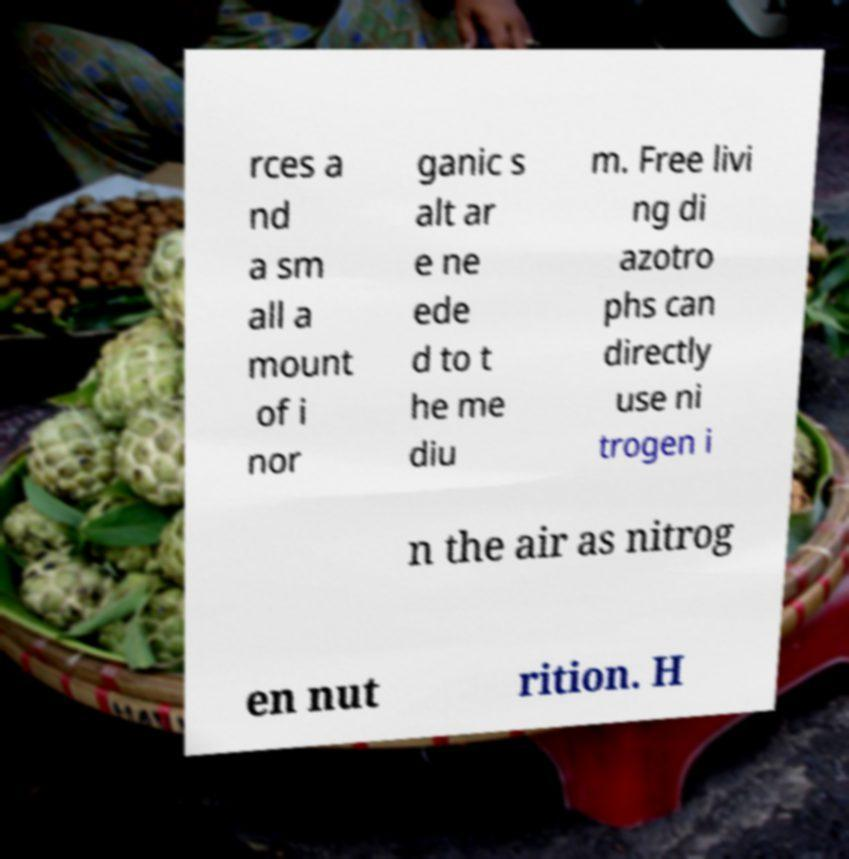What messages or text are displayed in this image? I need them in a readable, typed format. rces a nd a sm all a mount of i nor ganic s alt ar e ne ede d to t he me diu m. Free livi ng di azotro phs can directly use ni trogen i n the air as nitrog en nut rition. H 